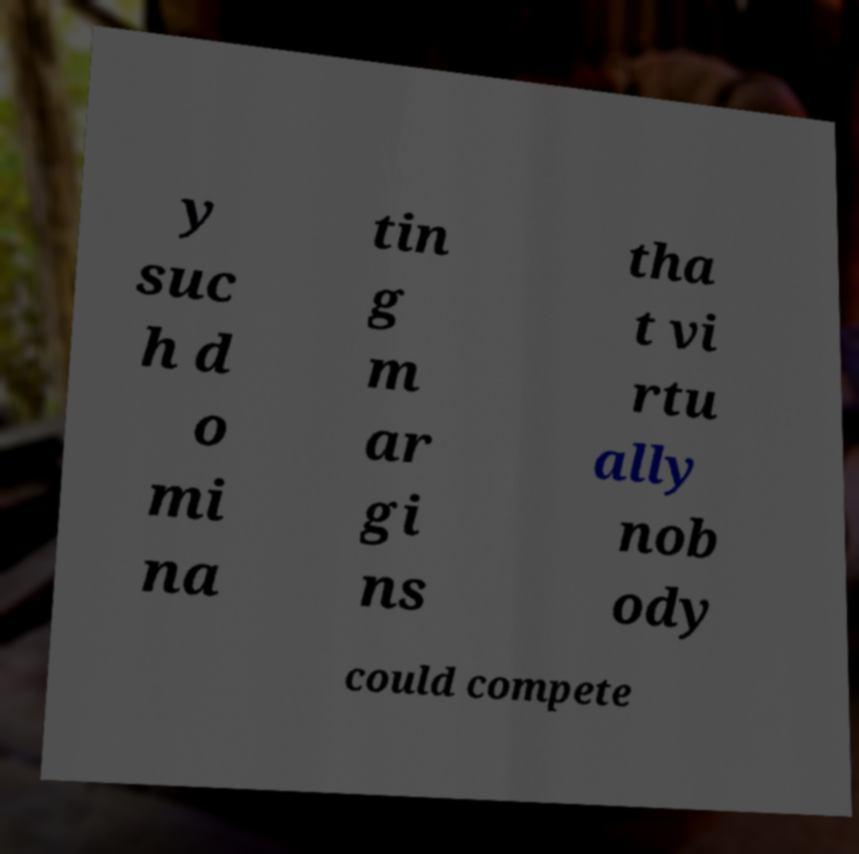Please read and relay the text visible in this image. What does it say? y suc h d o mi na tin g m ar gi ns tha t vi rtu ally nob ody could compete 